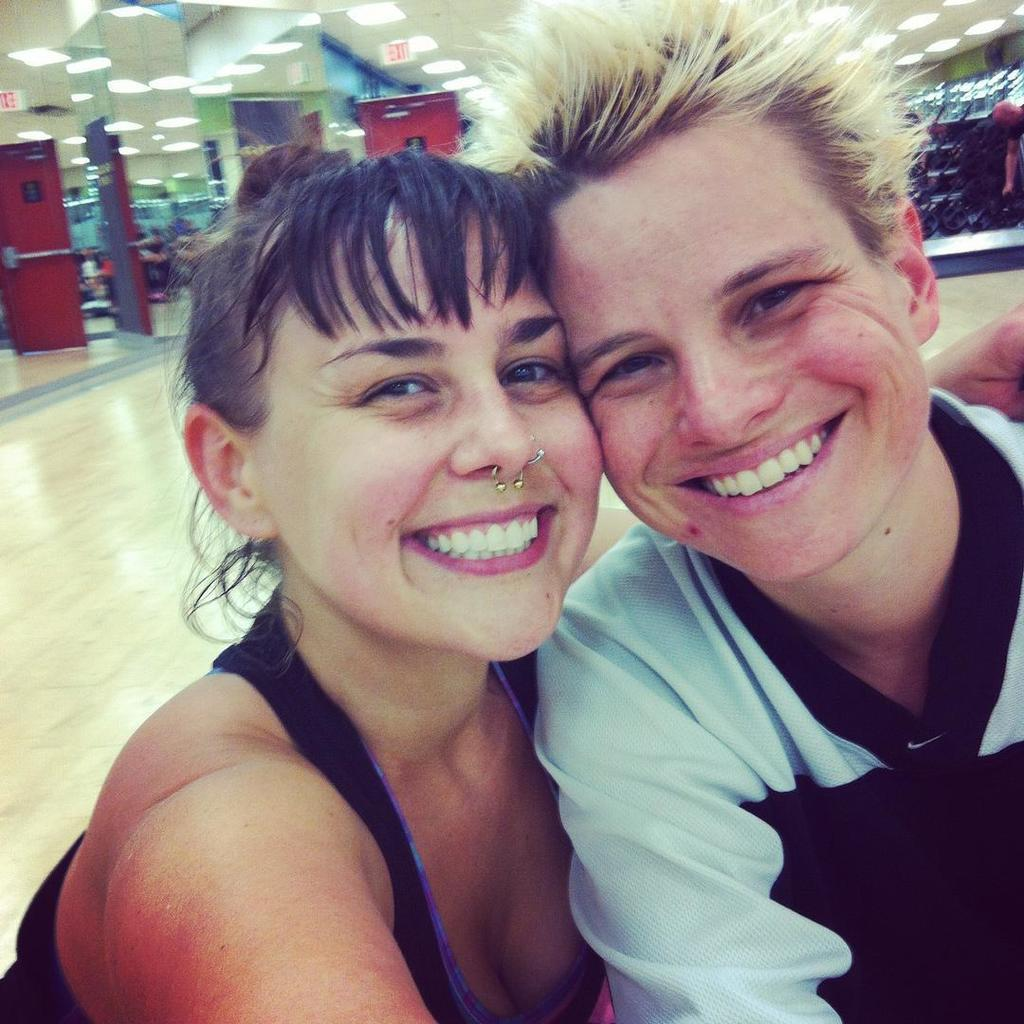How many people are in the image? There are persons in the image, but the exact number is not specified. What are the persons wearing? The persons are wearing clothes. What type of lighting is present in the image? There are lights on the ceiling. Where is the ceiling located in the image? The ceiling is at the top of the image. What type of amusement can be seen in the image? There is no amusement present in the image; it only features persons wearing clothes and lights on the ceiling. 